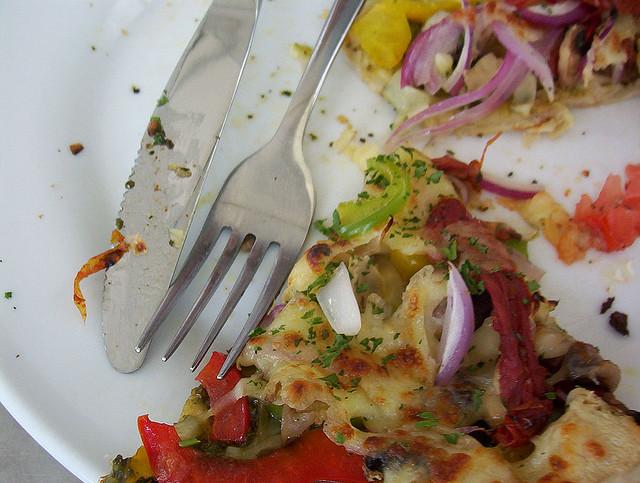Are the onions diced finely or chopped?
Short answer required. Chopped. Has the person eaten the food?
Answer briefly. Yes. What was the person using to eat their meal?
Short answer required. Fork and knife. 